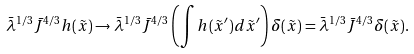Convert formula to latex. <formula><loc_0><loc_0><loc_500><loc_500>\bar { \lambda } ^ { 1 / 3 } \bar { J } ^ { 4 / 3 } h ( \tilde { x } ) \rightarrow \bar { \lambda } ^ { 1 / 3 } \bar { J } ^ { 4 / 3 } \left ( \int h ( \tilde { x } ^ { \prime } ) d \tilde { x } ^ { \prime } \right ) \delta ( \tilde { x } ) = \bar { \lambda } ^ { 1 / 3 } \bar { J } ^ { 4 / 3 } \delta ( \tilde { x } ) .</formula> 